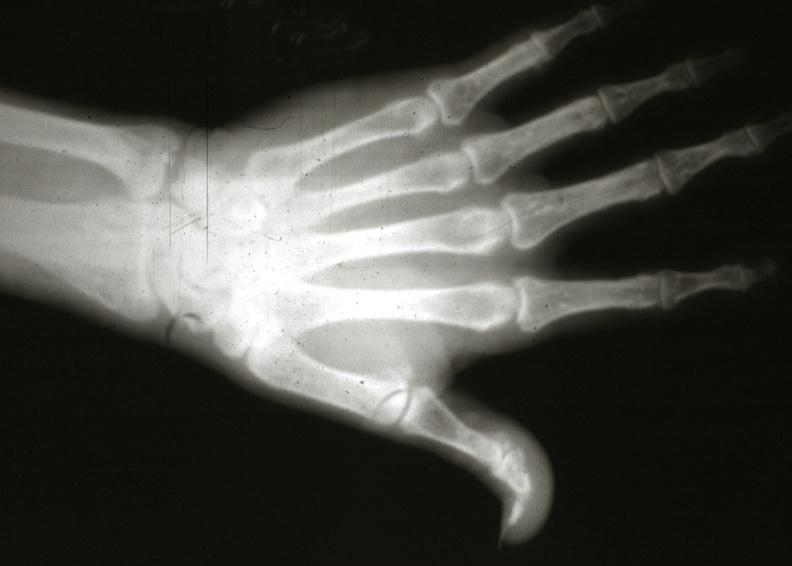s joints present?
Answer the question using a single word or phrase. Yes 